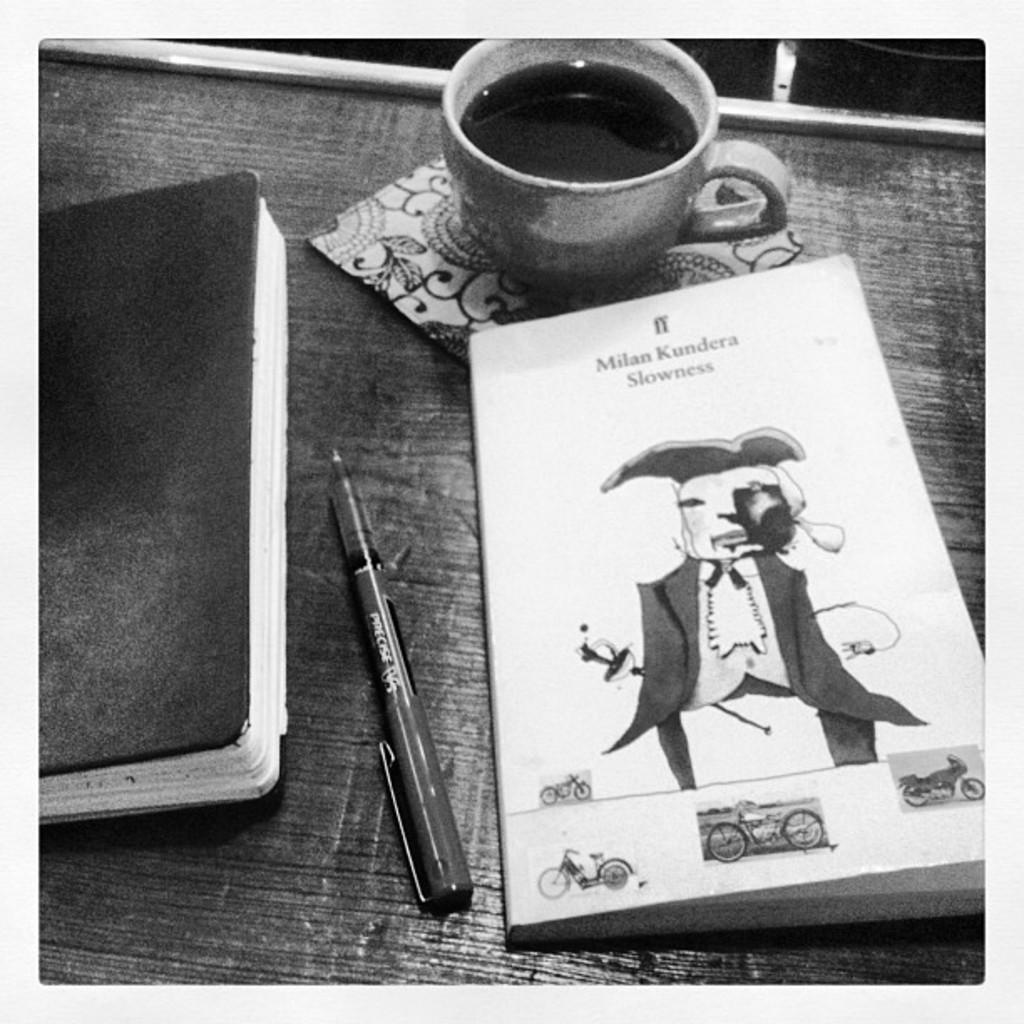Could you give a brief overview of what you see in this image? This is the black and white image where we can see diary, pen, notebook on which we can see pictures of motorbikes and a cup with a drink in it are placed on the wooden table. 